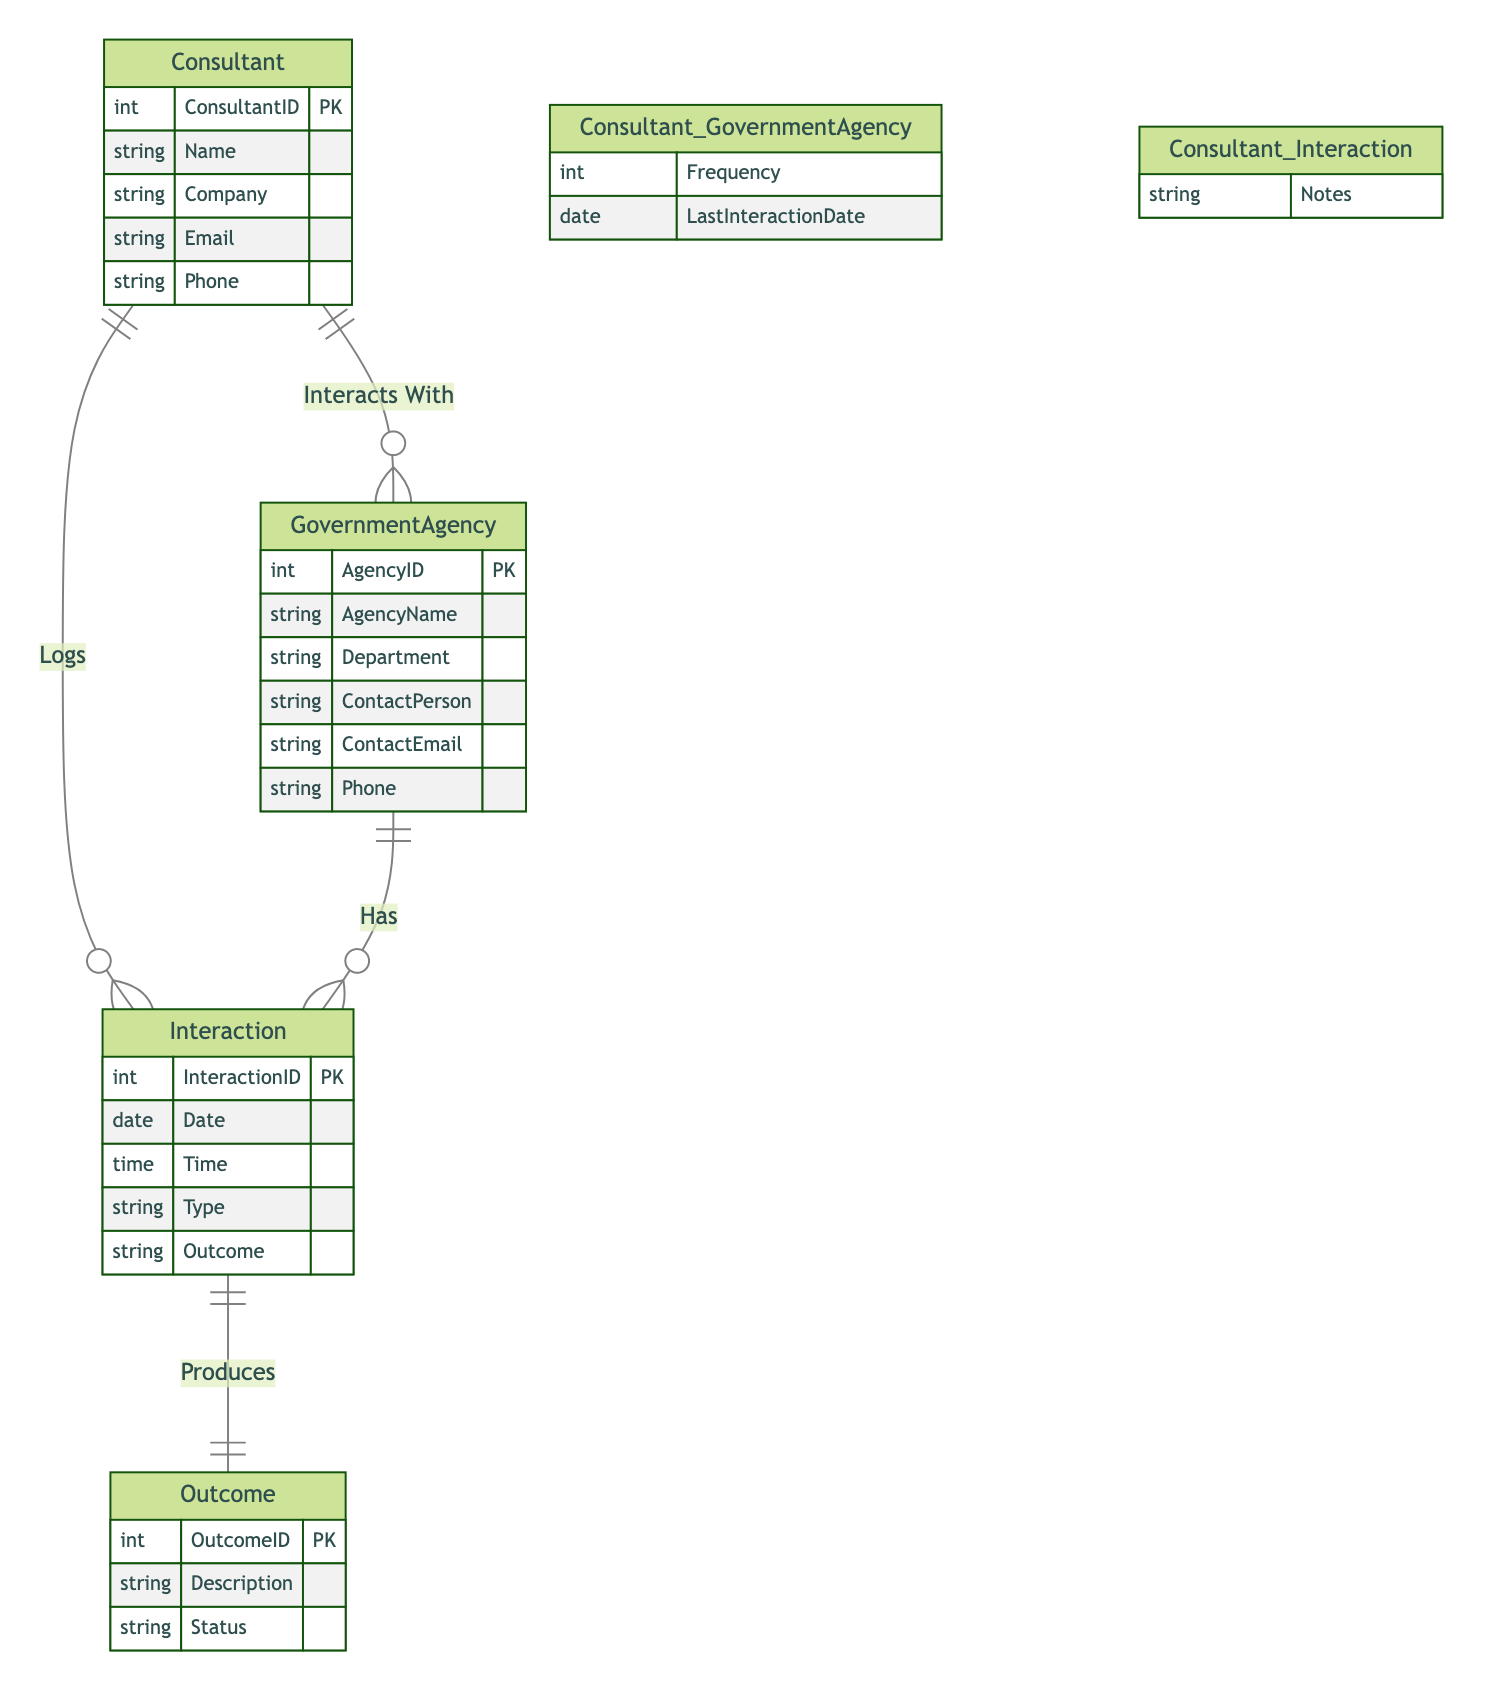What are the main entities represented in the diagram? The main entities represented are Consultant, Government Agency, Interaction, and Outcome. Each entity corresponds to a distinct table that captures various aspects of the interactions and relationships.
Answer: Consultant, Government Agency, Interaction, Outcome What is the relationship between Consultant and Government Agency? The relationship is that the Consultant interacts with the Government Agency, as depicted by the connection labeled "Interacts With". This indicates that there is a direct interaction process established between these two entities.
Answer: Interacts With How many attributes does the Government Agency entity have? The Government Agency entity has six attributes: AgencyID, AgencyName, Department, ContactPerson, ContactEmail, and Phone. These attributes describe the essential information pertaining to a government agency.
Answer: Six What is included in the Interaction entity? The Interaction entity includes attributes such as InteractionID, Date, Time, Type, and Outcome, detailing the characteristics of each interaction that takes place between the consultant and the government agencies.
Answer: InteractionID, Date, Time, Type, Outcome What is the significance of the "Produces" relationship in the diagram? The "Produces" relationship indicates that an Interaction results in an Outcome. This shows how each interaction can lead to specific results, aligning with the goals of the consultant's efforts in lobbying and engaging with the government agencies.
Answer: Produces What attribute captures the notes related to interactions logged by the consultant? The attribute that captures the notes related to interactions logged by the consultant is "Notes," which is part of the relationship "Consultant Logs Interaction." This allows the consultant to provide context or details about each interaction.
Answer: Notes Which entity serves as the primary record for tracking outcomes? The primary record for tracking outcomes is the Outcome entity, which contains attributes such as OutcomeID, Description, and Status, reflecting what each outcome entails and its current situation.
Answer: Outcome How many relationships exist between Consultant and Interaction? There are two relationships between Consultant and Interaction: "Logs" and "Interacts With". This indicates that the consultant both logs interactions and interacts with other entities in the diagram.
Answer: Two What does "Frequency" represent in the context of the relationship between Consultant and Government Agency? "Frequency" represents how often the Consultant interacts with the Government Agency, capturing the regularity of their engagements. This is a quantifiable measure that helps in understanding the intensity of the lobbying efforts.
Answer: Frequency 